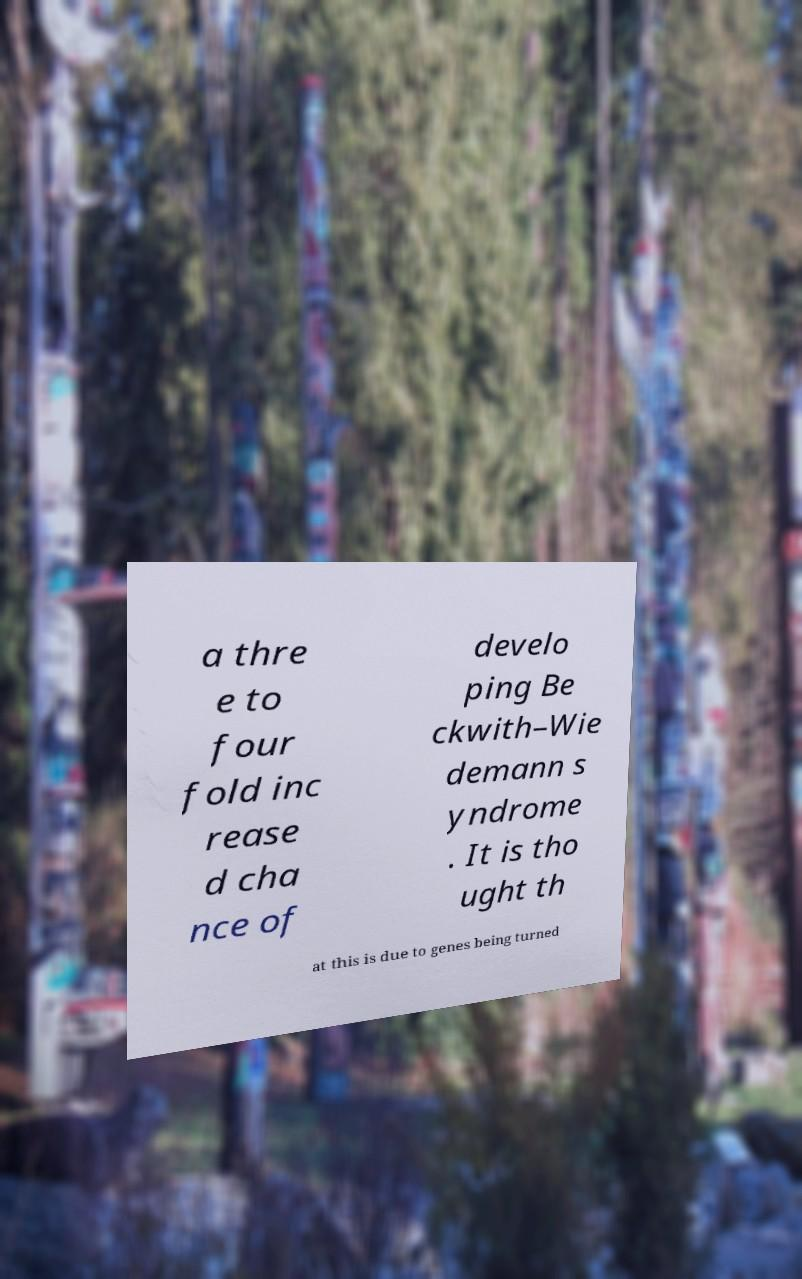There's text embedded in this image that I need extracted. Can you transcribe it verbatim? a thre e to four fold inc rease d cha nce of develo ping Be ckwith–Wie demann s yndrome . It is tho ught th at this is due to genes being turned 